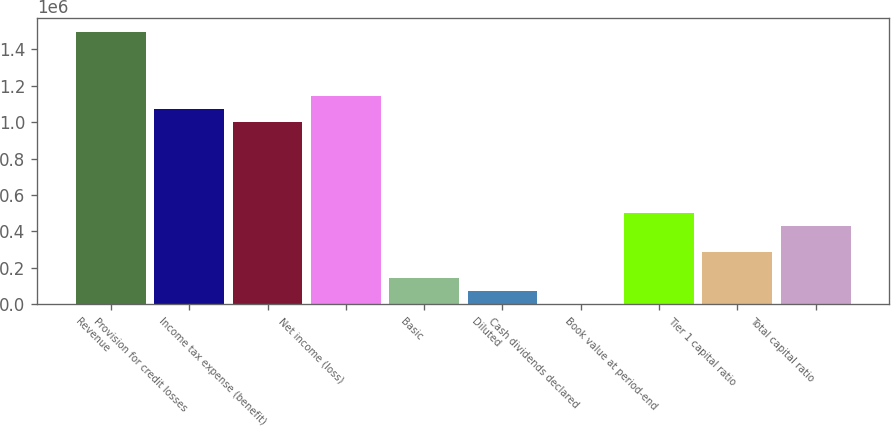Convert chart to OTSL. <chart><loc_0><loc_0><loc_500><loc_500><bar_chart><fcel>Revenue<fcel>Provision for credit losses<fcel>Income tax expense (benefit)<fcel>Net income (loss)<fcel>Basic<fcel>Diluted<fcel>Cash dividends declared<fcel>Book value at period-end<fcel>Tier 1 capital ratio<fcel>Total capital ratio<nl><fcel>1.49627e+06<fcel>1.06876e+06<fcel>997511<fcel>1.14001e+06<fcel>142502<fcel>71251.1<fcel>0.34<fcel>498756<fcel>285003<fcel>427505<nl></chart> 